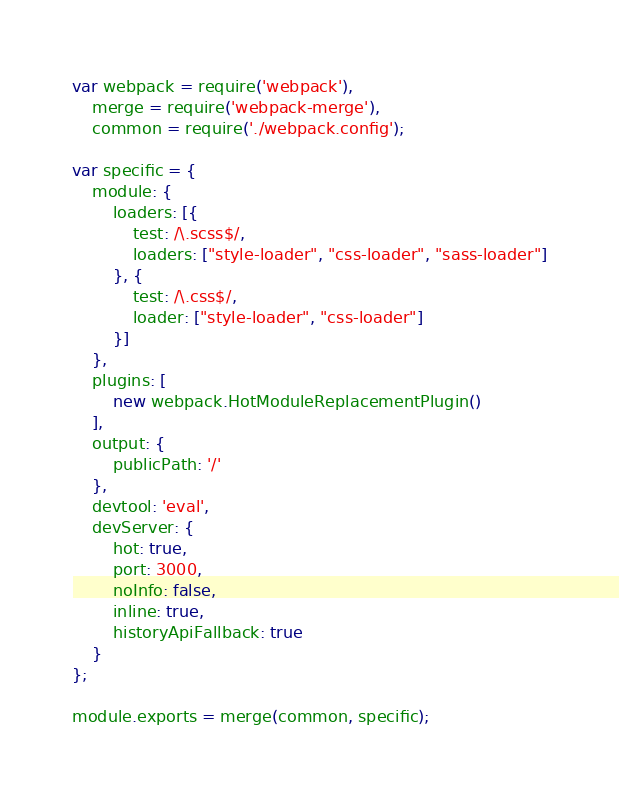Convert code to text. <code><loc_0><loc_0><loc_500><loc_500><_JavaScript_>var webpack = require('webpack'),
    merge = require('webpack-merge'),
    common = require('./webpack.config');

var specific = {
    module: {
        loaders: [{
            test: /\.scss$/,
            loaders: ["style-loader", "css-loader", "sass-loader"]
        }, {
            test: /\.css$/,
            loader: ["style-loader", "css-loader"]
        }]
    },
    plugins: [
        new webpack.HotModuleReplacementPlugin()
    ],
    output: {
        publicPath: '/'
    },
    devtool: 'eval',
    devServer: {
        hot: true,
        port: 3000,
        noInfo: false,
        inline: true,
        historyApiFallback: true
    }
};

module.exports = merge(common, specific);
</code> 